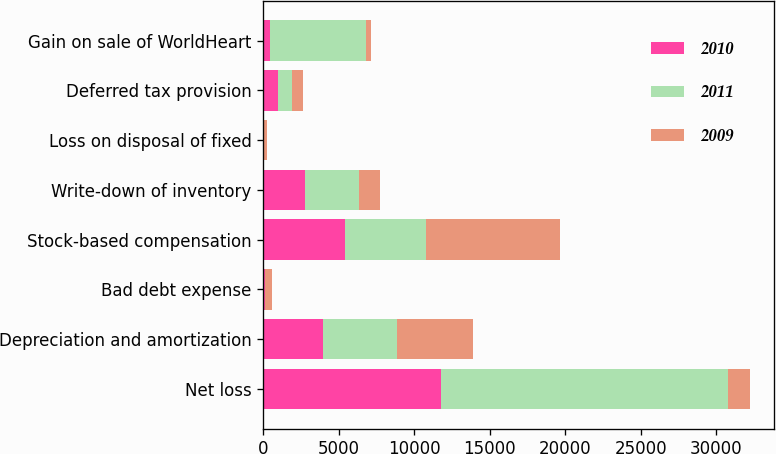Convert chart to OTSL. <chart><loc_0><loc_0><loc_500><loc_500><stacked_bar_chart><ecel><fcel>Net loss<fcel>Depreciation and amortization<fcel>Bad debt expense<fcel>Stock-based compensation<fcel>Write-down of inventory<fcel>Loss on disposal of fixed<fcel>Deferred tax provision<fcel>Gain on sale of WorldHeart<nl><fcel>2010<fcel>11755<fcel>3948<fcel>139<fcel>5421<fcel>2781<fcel>29<fcel>970<fcel>456<nl><fcel>2011<fcel>19024<fcel>4898<fcel>22<fcel>5365<fcel>3536<fcel>54<fcel>954<fcel>6389<nl><fcel>2009<fcel>1444<fcel>5016<fcel>438<fcel>8834<fcel>1444<fcel>165<fcel>721<fcel>313<nl></chart> 